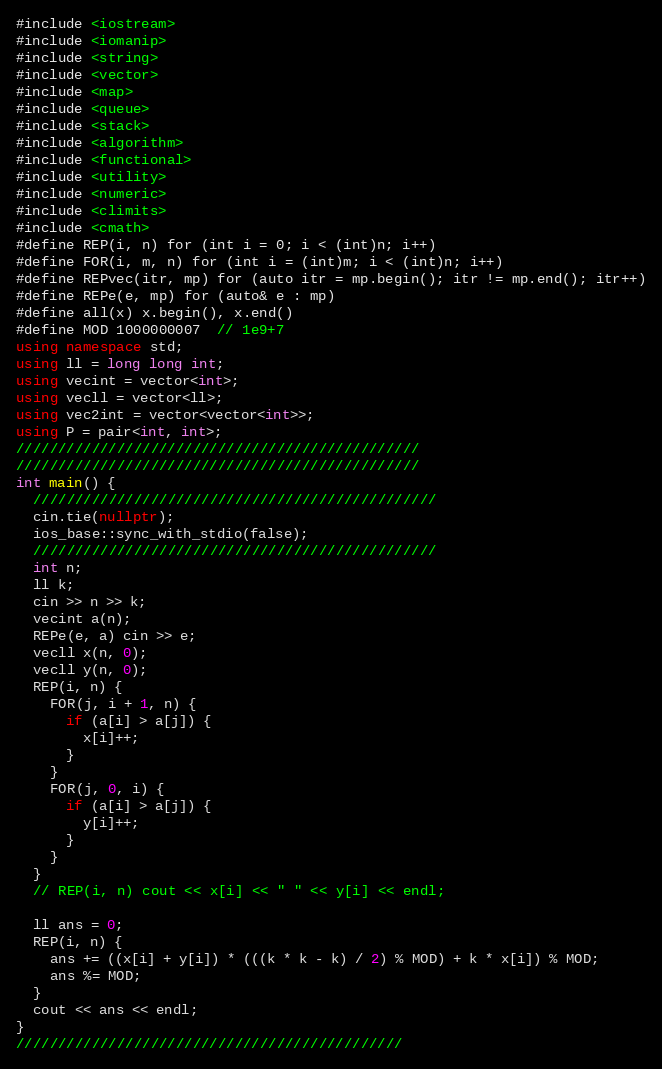<code> <loc_0><loc_0><loc_500><loc_500><_C++_>#include <iostream>
#include <iomanip>
#include <string>
#include <vector>
#include <map>
#include <queue>
#include <stack>
#include <algorithm>
#include <functional>
#include <utility>
#include <numeric>
#include <climits>
#include <cmath>
#define REP(i, n) for (int i = 0; i < (int)n; i++)
#define FOR(i, m, n) for (int i = (int)m; i < (int)n; i++)
#define REPvec(itr, mp) for (auto itr = mp.begin(); itr != mp.end(); itr++)
#define REPe(e, mp) for (auto& e : mp)
#define all(x) x.begin(), x.end()
#define MOD 1000000007  // 1e9+7
using namespace std;
using ll = long long int;
using vecint = vector<int>;
using vecll = vector<ll>;
using vec2int = vector<vector<int>>;
using P = pair<int, int>;
////////////////////////////////////////////////
////////////////////////////////////////////////
int main() {
  ////////////////////////////////////////////////
  cin.tie(nullptr);
  ios_base::sync_with_stdio(false);
  ////////////////////////////////////////////////
  int n;
  ll k;
  cin >> n >> k;
  vecint a(n);
  REPe(e, a) cin >> e;
  vecll x(n, 0);
  vecll y(n, 0);
  REP(i, n) {
    FOR(j, i + 1, n) {
      if (a[i] > a[j]) {
        x[i]++;
      }
    }
    FOR(j, 0, i) {
      if (a[i] > a[j]) {
        y[i]++;
      }
    }
  }
  // REP(i, n) cout << x[i] << " " << y[i] << endl;

  ll ans = 0;
  REP(i, n) {
    ans += ((x[i] + y[i]) * (((k * k - k) / 2) % MOD) + k * x[i]) % MOD;
    ans %= MOD;
  }
  cout << ans << endl;
}
//////////////////////////////////////////////
</code> 